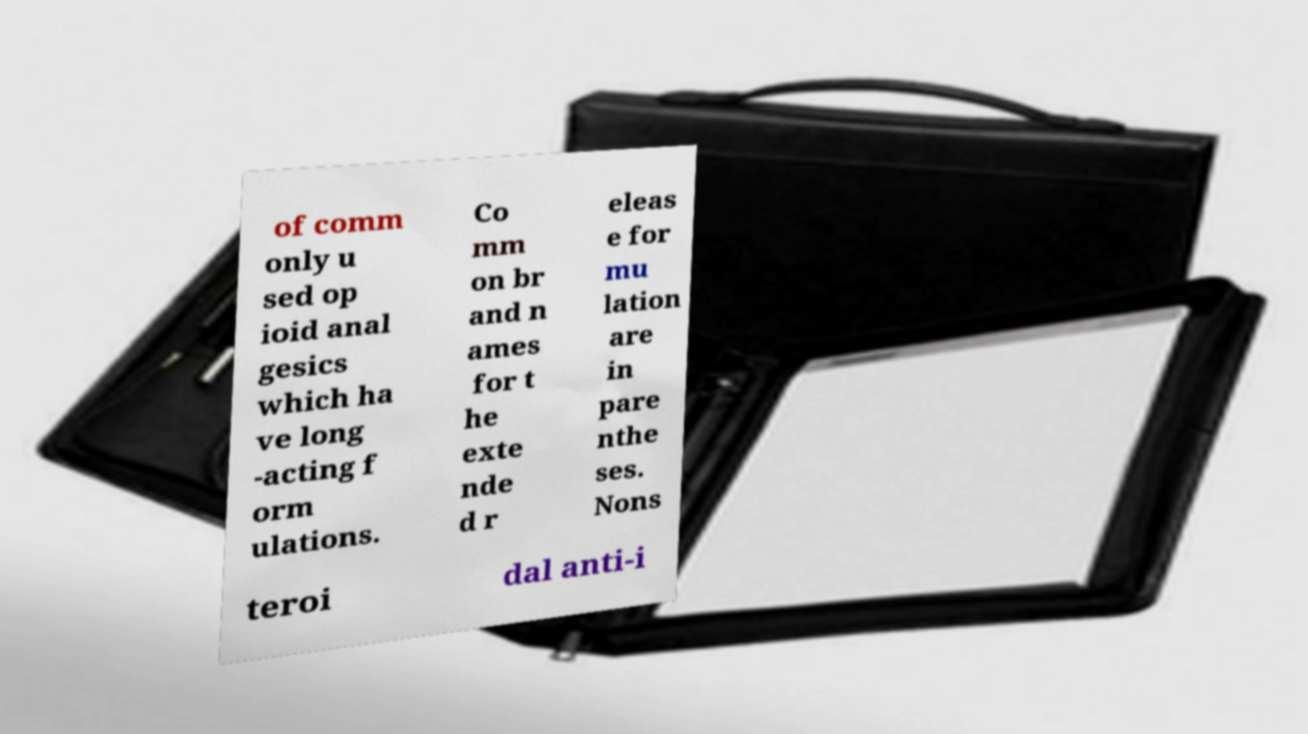What messages or text are displayed in this image? I need them in a readable, typed format. of comm only u sed op ioid anal gesics which ha ve long -acting f orm ulations. Co mm on br and n ames for t he exte nde d r eleas e for mu lation are in pare nthe ses. Nons teroi dal anti-i 